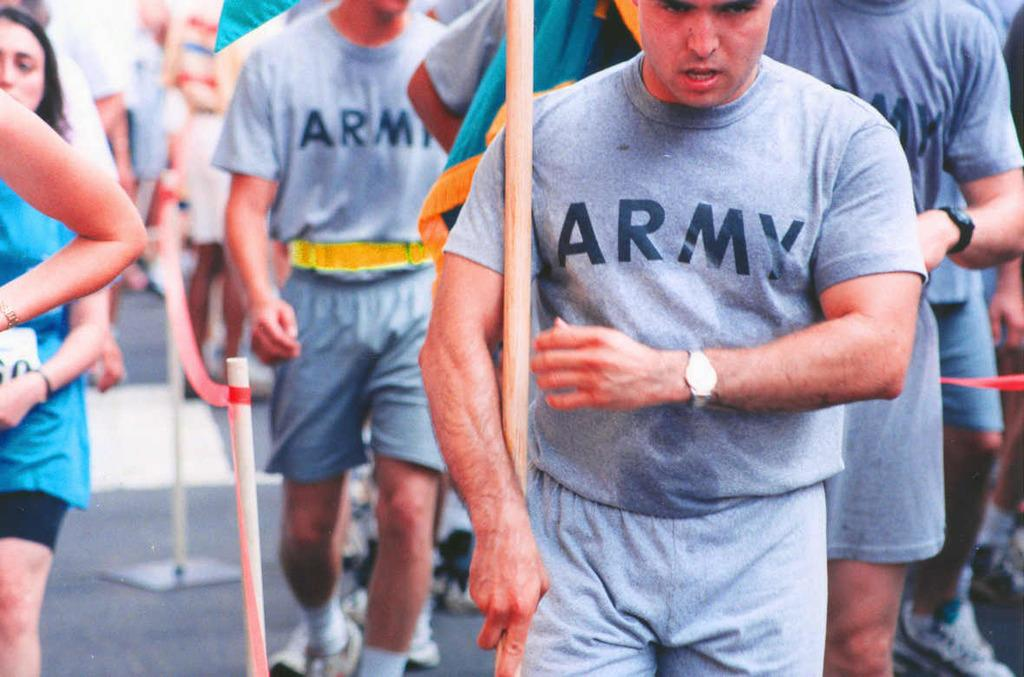<image>
Give a short and clear explanation of the subsequent image. Mean wearing gray Army tshirts next to runners in a marathon. 